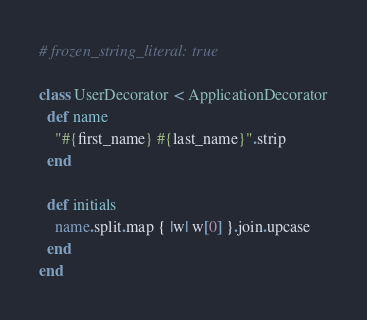<code> <loc_0><loc_0><loc_500><loc_500><_Ruby_># frozen_string_literal: true

class UserDecorator < ApplicationDecorator
  def name
    "#{first_name} #{last_name}".strip
  end

  def initials
    name.split.map { |w| w[0] }.join.upcase
  end
end
</code> 